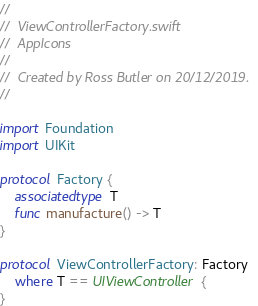Convert code to text. <code><loc_0><loc_0><loc_500><loc_500><_Swift_>//
//  ViewControllerFactory.swift
//  AppIcons
//
//  Created by Ross Butler on 20/12/2019.
//

import Foundation
import UIKit

protocol Factory {
    associatedtype T
    func manufacture() -> T
}

protocol ViewControllerFactory: Factory
    where T == UIViewController {
}
</code> 